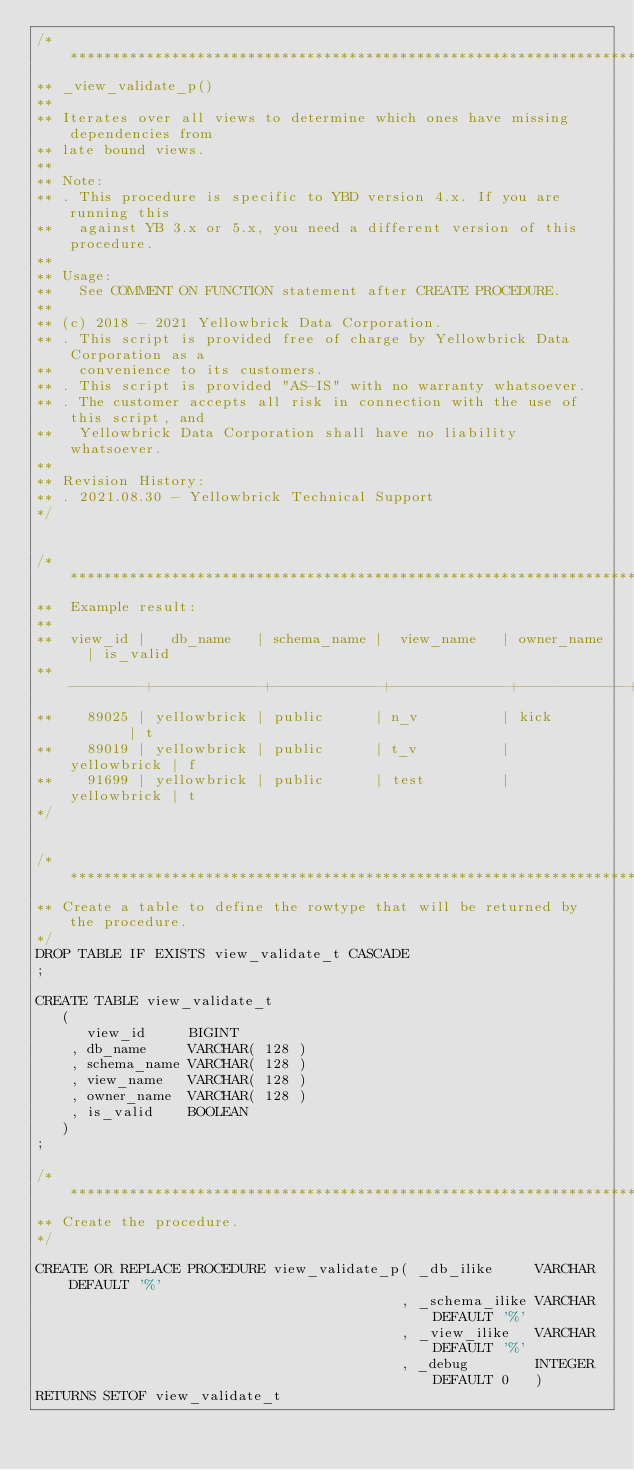<code> <loc_0><loc_0><loc_500><loc_500><_SQL_>/* ****************************************************************************
** _view_validate_p() 
** 
** Iterates over all views to determine which ones have missing dependencies from
** late bound views.  
** 
** Note:
** . This procedure is specific to YBD version 4.x. If you are running this 
**   against YB 3.x or 5.x, you need a different version of this procedure. 
**
** Usage:
**   See COMMENT ON FUNCTION statement after CREATE PROCEDURE.
**
** (c) 2018 - 2021 Yellowbrick Data Corporation.
** . This script is provided free of charge by Yellowbrick Data Corporation as a 
**   convenience to its customers.
** . This script is provided "AS-IS" with no warranty whatsoever.
** . The customer accepts all risk in connection with the use of this script, and
**   Yellowbrick Data Corporation shall have no liability whatsoever.
**
** Revision History:
** . 2021.08.30 - Yellowbrick Technical Support 
*/
 
 
/* ****************************************************************************
**  Example result:
** 
**  view_id |   db_name   | schema_name |  view_name   | owner_name  | is_valid
** ---------+-------------+-------------+--------------+-------------+----------
**    89025 | yellowbrick | public      | n_v          | kick        | t
**    89019 | yellowbrick | public      | t_v          | yellowbrick | f
**    91699 | yellowbrick | public      | test         | yellowbrick | t
*/


/* ****************************************************************************
** Create a table to define the rowtype that will be returned by the procedure.
*/
DROP TABLE IF EXISTS view_validate_t CASCADE
;

CREATE TABLE view_validate_t
   (
      view_id     BIGINT
    , db_name     VARCHAR( 128 )
    , schema_name VARCHAR( 128 ) 
    , view_name   VARCHAR( 128 )    
    , owner_name  VARCHAR( 128 ) 
    , is_valid    BOOLEAN
   )
;  

/* ****************************************************************************
** Create the procedure.
*/

CREATE OR REPLACE PROCEDURE view_validate_p( _db_ilike     VARCHAR DEFAULT '%'
                                           , _schema_ilike VARCHAR DEFAULT '%'
                                           , _view_ilike   VARCHAR DEFAULT '%'
                                           , _debug        INTEGER DEFAULT 0   )
RETURNS SETOF view_validate_t</code> 